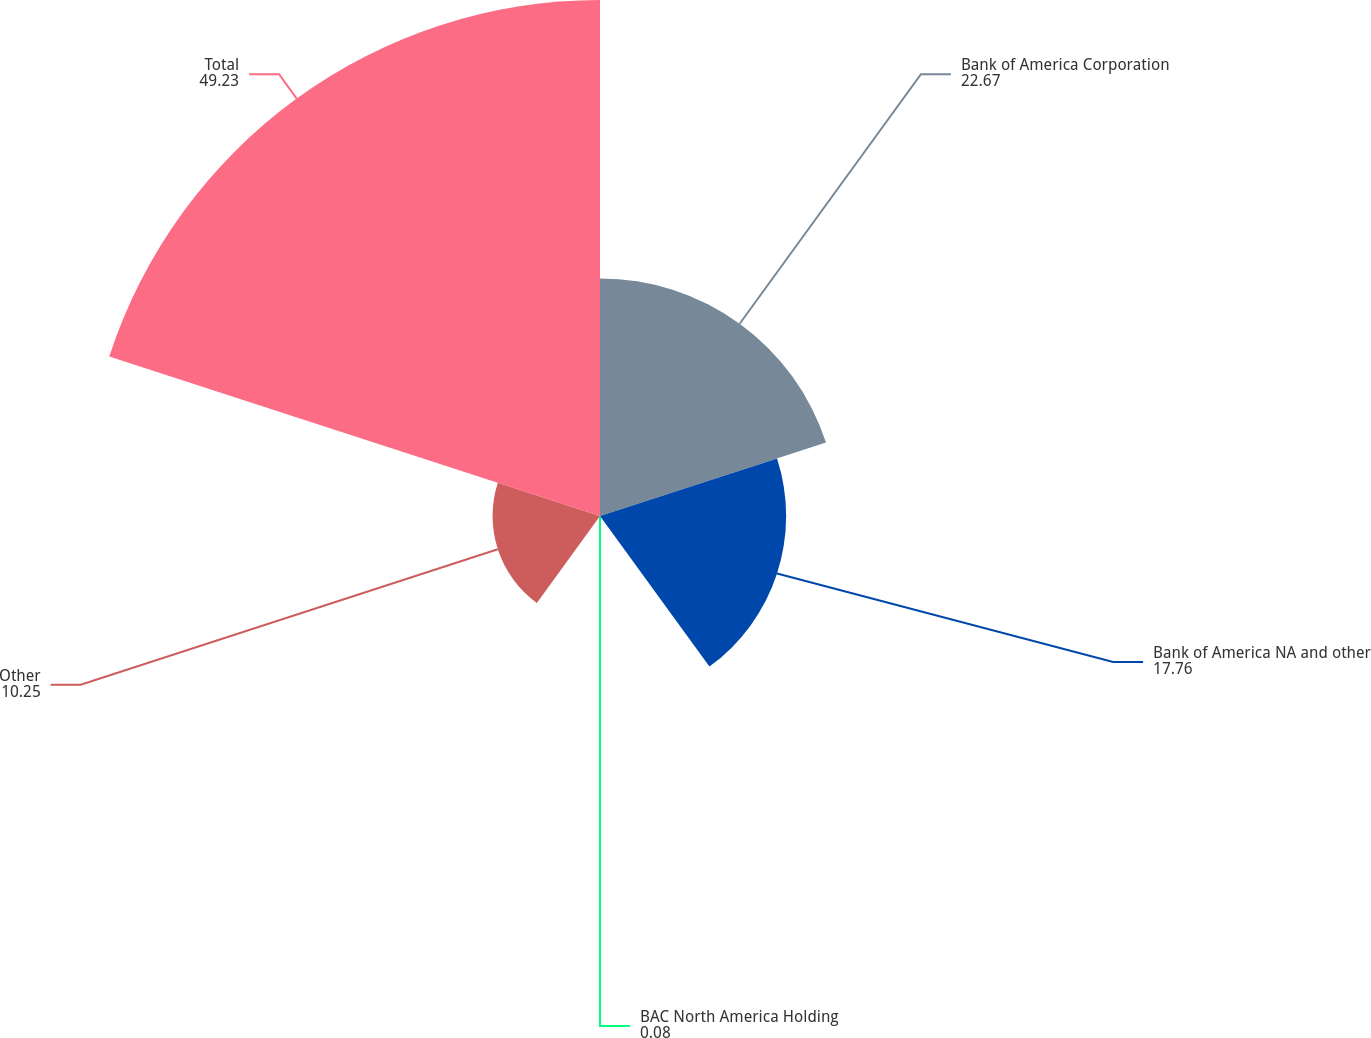Convert chart to OTSL. <chart><loc_0><loc_0><loc_500><loc_500><pie_chart><fcel>Bank of America Corporation<fcel>Bank of America NA and other<fcel>BAC North America Holding<fcel>Other<fcel>Total<nl><fcel>22.67%<fcel>17.76%<fcel>0.08%<fcel>10.25%<fcel>49.23%<nl></chart> 